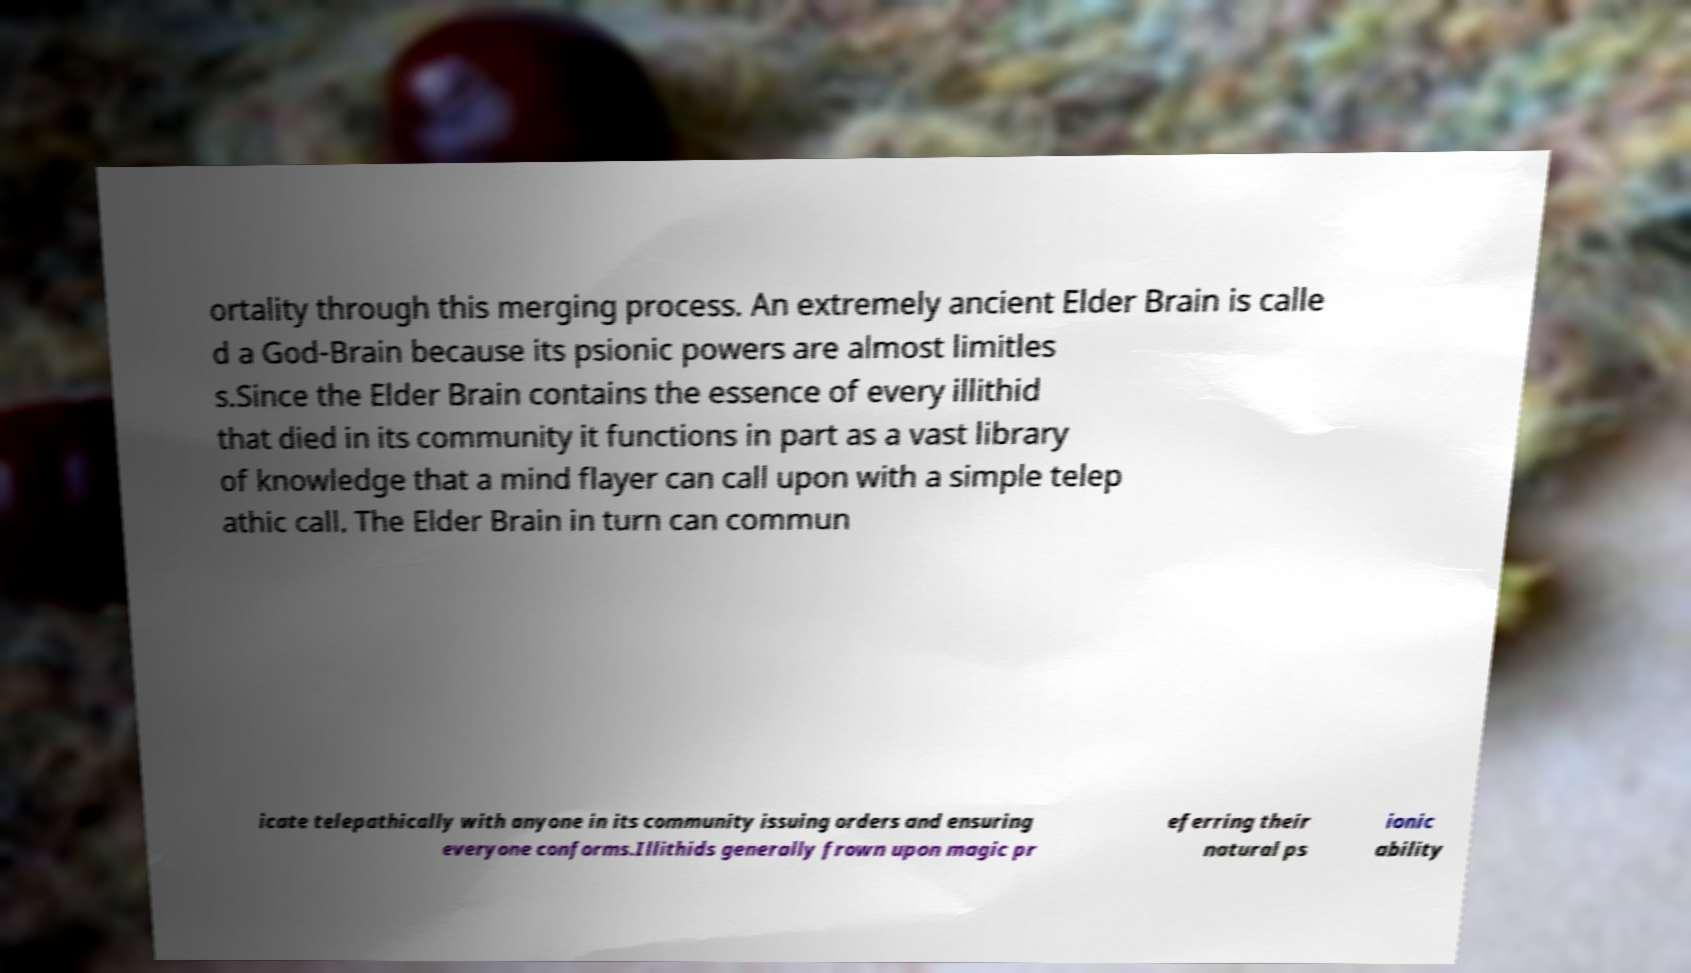What messages or text are displayed in this image? I need them in a readable, typed format. ortality through this merging process. An extremely ancient Elder Brain is calle d a God-Brain because its psionic powers are almost limitles s.Since the Elder Brain contains the essence of every illithid that died in its community it functions in part as a vast library of knowledge that a mind flayer can call upon with a simple telep athic call. The Elder Brain in turn can commun icate telepathically with anyone in its community issuing orders and ensuring everyone conforms.Illithids generally frown upon magic pr eferring their natural ps ionic ability 